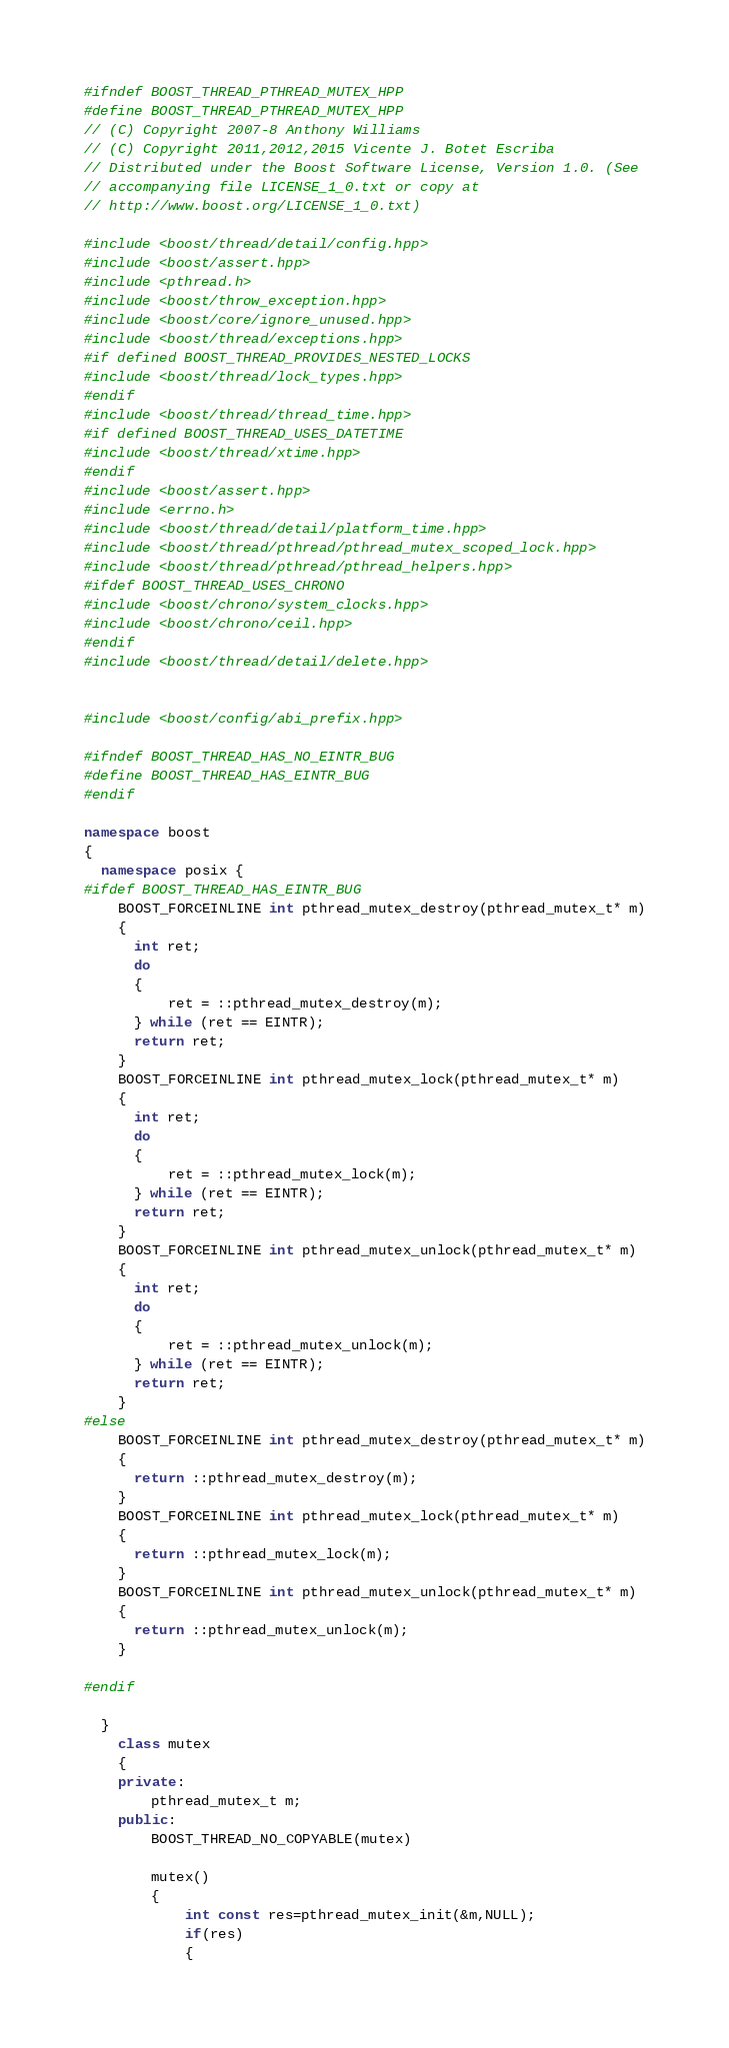<code> <loc_0><loc_0><loc_500><loc_500><_C++_>#ifndef BOOST_THREAD_PTHREAD_MUTEX_HPP
#define BOOST_THREAD_PTHREAD_MUTEX_HPP
// (C) Copyright 2007-8 Anthony Williams
// (C) Copyright 2011,2012,2015 Vicente J. Botet Escriba
// Distributed under the Boost Software License, Version 1.0. (See
// accompanying file LICENSE_1_0.txt or copy at
// http://www.boost.org/LICENSE_1_0.txt)

#include <boost/thread/detail/config.hpp>
#include <boost/assert.hpp>
#include <pthread.h>
#include <boost/throw_exception.hpp>
#include <boost/core/ignore_unused.hpp>
#include <boost/thread/exceptions.hpp>
#if defined BOOST_THREAD_PROVIDES_NESTED_LOCKS
#include <boost/thread/lock_types.hpp>
#endif
#include <boost/thread/thread_time.hpp>
#if defined BOOST_THREAD_USES_DATETIME
#include <boost/thread/xtime.hpp>
#endif
#include <boost/assert.hpp>
#include <errno.h>
#include <boost/thread/detail/platform_time.hpp>
#include <boost/thread/pthread/pthread_mutex_scoped_lock.hpp>
#include <boost/thread/pthread/pthread_helpers.hpp>
#ifdef BOOST_THREAD_USES_CHRONO
#include <boost/chrono/system_clocks.hpp>
#include <boost/chrono/ceil.hpp>
#endif
#include <boost/thread/detail/delete.hpp>


#include <boost/config/abi_prefix.hpp>

#ifndef BOOST_THREAD_HAS_NO_EINTR_BUG
#define BOOST_THREAD_HAS_EINTR_BUG
#endif

namespace boost
{
  namespace posix {
#ifdef BOOST_THREAD_HAS_EINTR_BUG
    BOOST_FORCEINLINE int pthread_mutex_destroy(pthread_mutex_t* m)
    {
      int ret;
      do
      {
          ret = ::pthread_mutex_destroy(m);
      } while (ret == EINTR);
      return ret;
    }
    BOOST_FORCEINLINE int pthread_mutex_lock(pthread_mutex_t* m)
    {
      int ret;
      do
      {
          ret = ::pthread_mutex_lock(m);
      } while (ret == EINTR);
      return ret;
    }
    BOOST_FORCEINLINE int pthread_mutex_unlock(pthread_mutex_t* m)
    {
      int ret;
      do
      {
          ret = ::pthread_mutex_unlock(m);
      } while (ret == EINTR);
      return ret;
    }
#else
    BOOST_FORCEINLINE int pthread_mutex_destroy(pthread_mutex_t* m)
    {
      return ::pthread_mutex_destroy(m);
    }
    BOOST_FORCEINLINE int pthread_mutex_lock(pthread_mutex_t* m)
    {
      return ::pthread_mutex_lock(m);
    }
    BOOST_FORCEINLINE int pthread_mutex_unlock(pthread_mutex_t* m)
    {
      return ::pthread_mutex_unlock(m);
    }

#endif

  }
    class mutex
    {
    private:
        pthread_mutex_t m;
    public:
        BOOST_THREAD_NO_COPYABLE(mutex)

        mutex()
        {
            int const res=pthread_mutex_init(&m,NULL);
            if(res)
            {</code> 